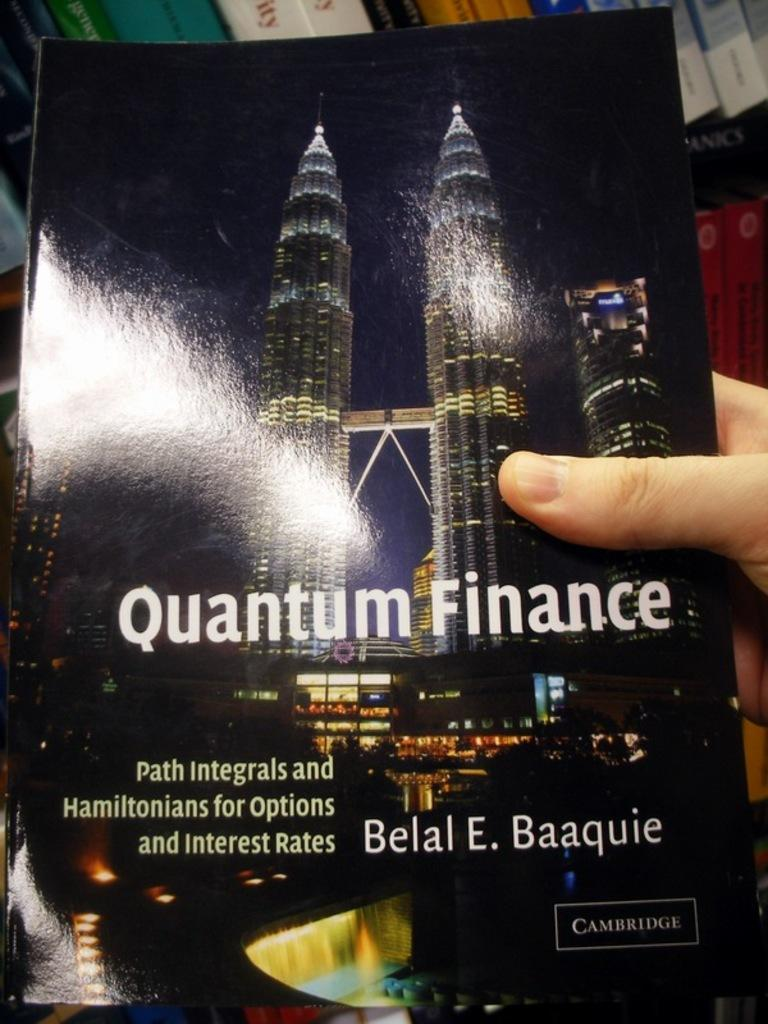What is the person in the image holding? The person is holding a book in the image. What can be seen on the cover of the book? The book has images of buildings on it. Is there any text on the book? Yes, the book has text on it. What else can be seen in the image related to books? There are shelves with books in the image. What type of oil is being used to comb the person's hair in the image? There is no hair combing or oil usage depicted in the image; the person is simply holding a book. 